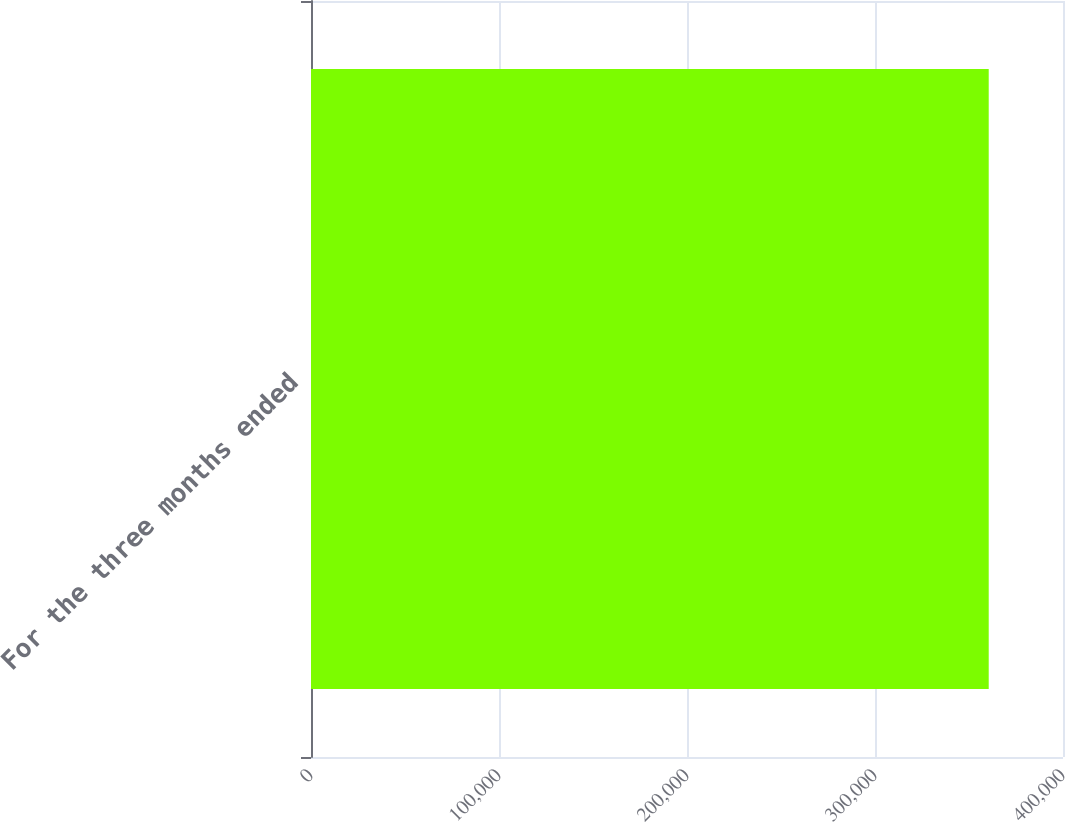Convert chart. <chart><loc_0><loc_0><loc_500><loc_500><bar_chart><fcel>For the three months ended<nl><fcel>360488<nl></chart> 